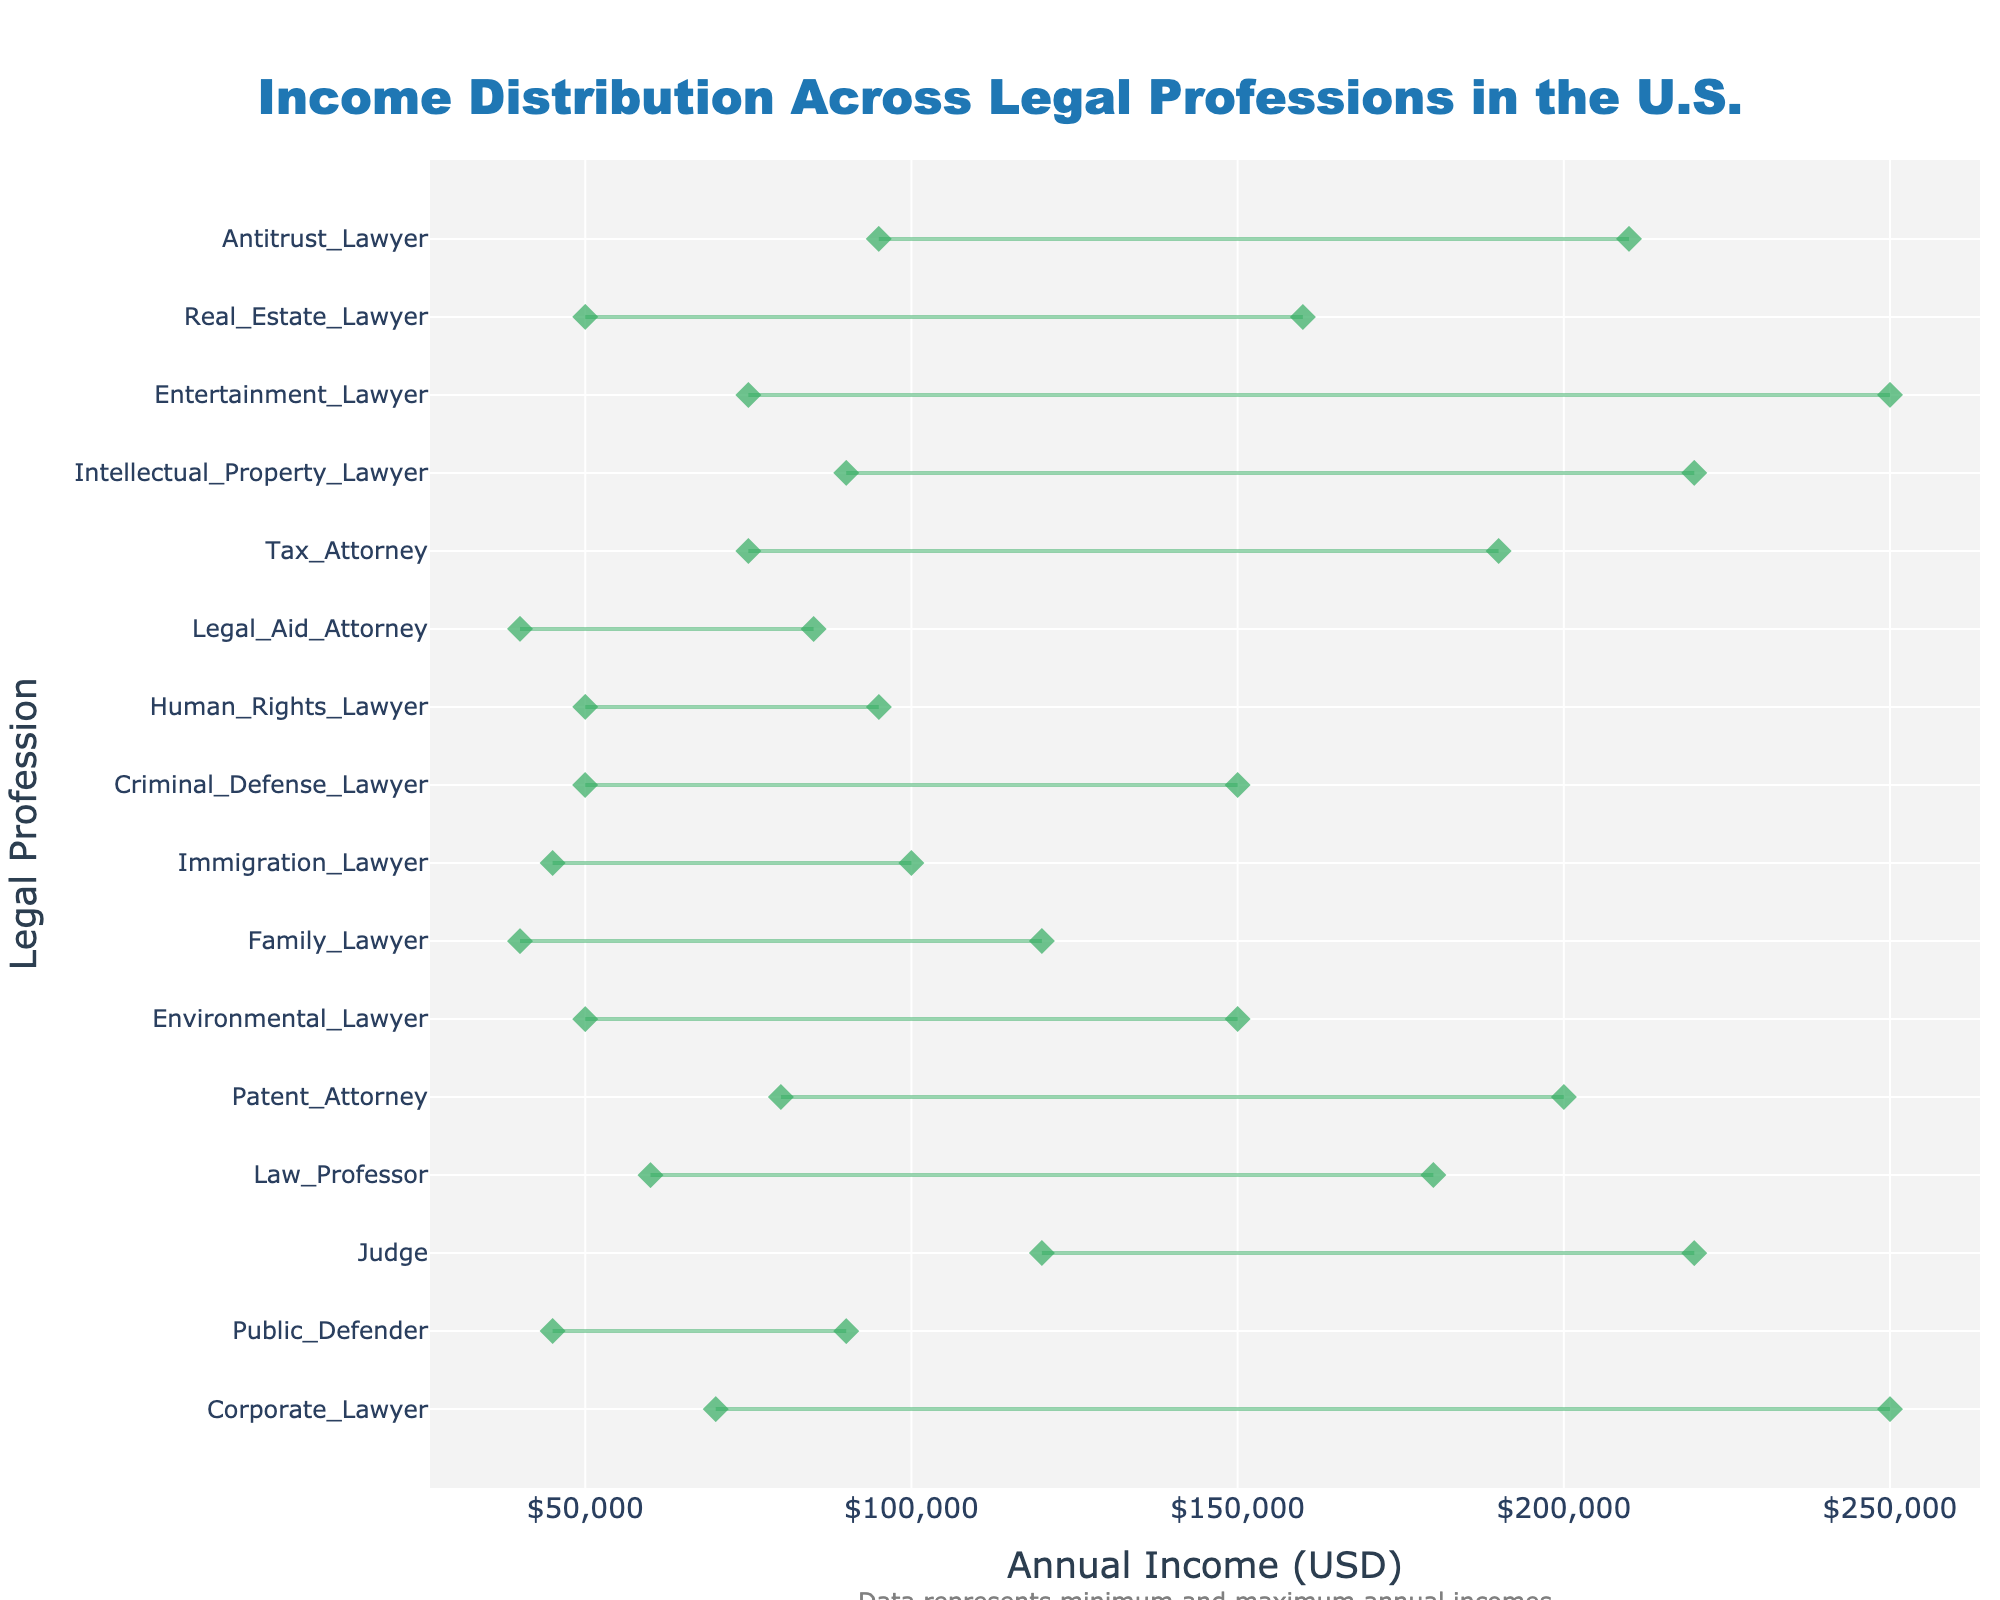What's the title of the figure? The title is displayed at the top of the figure and provides a clear indication of what the plot represents.
Answer: Income Distribution Across Legal Professions in the U.S What's the range of incomes for Corporate Lawyers? To find the range, look at the x-axis positions of the markers connected by the line labeled "Corporate Lawyer". They extend from $70,000 to $250,000.
Answer: $70,000 to $250,000 Which legal profession has the highest minimum income? Compare all the minimum incomes displayed on the plot to find the profession with the highest starting point. The highest minimum income is for Intellectual Property Lawyers at $90,000.
Answer: Intellectual Property Lawyer How much wider is the income range for Corporate Lawyers compared to Public Defenders? Calculate the range (Maximum - Minimum) for both professions and find the difference. Corporate Lawyer: $250,000 - $70,000 = $180,000; Public Defender: $90,000 - $45,000 = $45,000. Difference: $180,000 - $45,000 = $135,000.
Answer: $135,000 Which two legal professions have overlapping income ranges between $50,000 to $150,000? Identify the professions whose lines fall within the range of $50,000 to $150,000. These are Environmental Lawyers and Criminal Defense Lawyers.
Answer: Environmental Lawyer, Criminal Defense Lawyer What is the median value of the income range for Judges? Calculate the median by adding the minimum and maximum incomes and dividing by 2. Judge: ($120,000 + $220,000) / 2 = $170,000.
Answer: $170,000 Which legal profession has the smallest income range? Determine the range (Maximum - Minimum) for each profession and identify which one is the smallest. Legal Aid Attorney: $85,000 - $40,000 = $45,000.
Answer: Legal Aid Attorney What's the difference between the maximum incomes of Tax Attorney and Real Estate Lawyer? Find the maximum incomes for both professions and calculate the difference. Tax Attorney: $190,000; Real Estate Lawyer: $160,000. Difference: $190,000 - $160,000 = $30,000.
Answer: $30,000 How does the income range of Entertainment Lawyers compare to that of Antitrust Lawyers? Compare both ranges by calculating the difference between maximum and minimum incomes. Entertainment Lawyer: $250,000 - $75,000 = $175,000; Antitrust Lawyer: $210,000 - $95,000 = $115,000. Difference: $175,000 - $115,000 = $60,000.
Answer: Entertainment Lawyers have a $60,000 wider range 